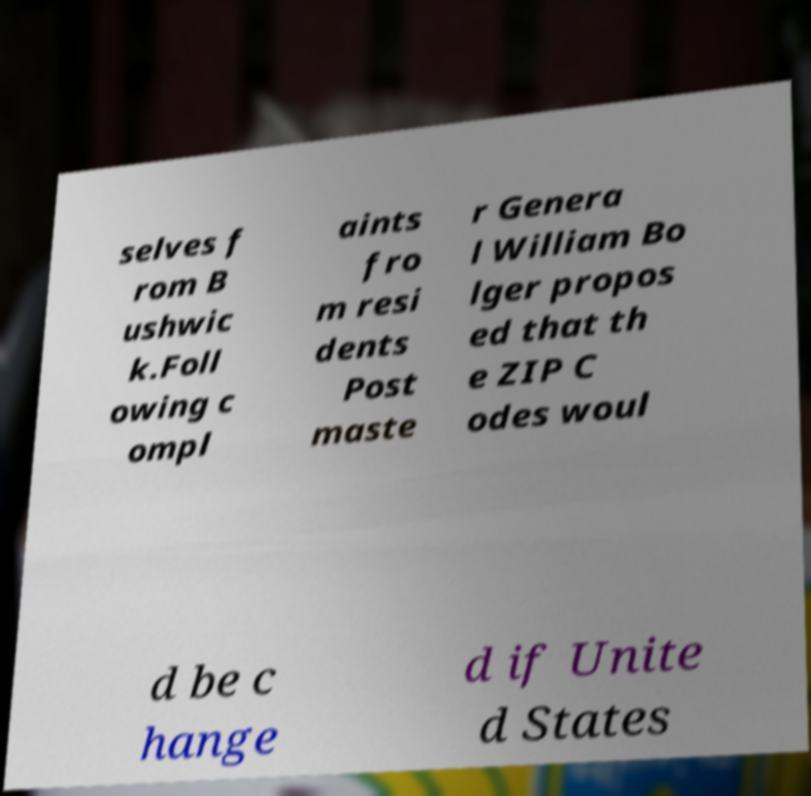Could you assist in decoding the text presented in this image and type it out clearly? selves f rom B ushwic k.Foll owing c ompl aints fro m resi dents Post maste r Genera l William Bo lger propos ed that th e ZIP C odes woul d be c hange d if Unite d States 